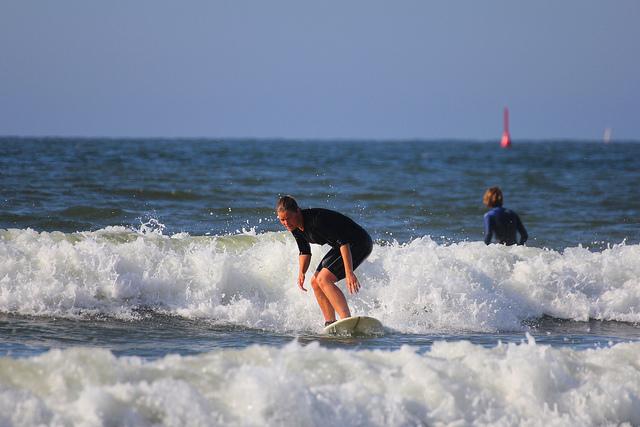What direction is the guy in back facing?
Quick response, please. Away. How many People are there?
Be succinct. 2. Is the man standing on the surfboard?
Keep it brief. Yes. Is there snow in this photo?
Write a very short answer. No. 